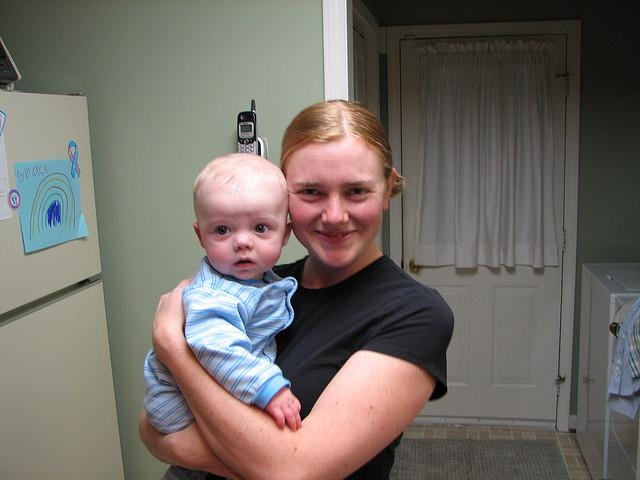Why is she smiling?

Choices:
A) is confused
B) has child
C) is proud
D) selling baby is proud 